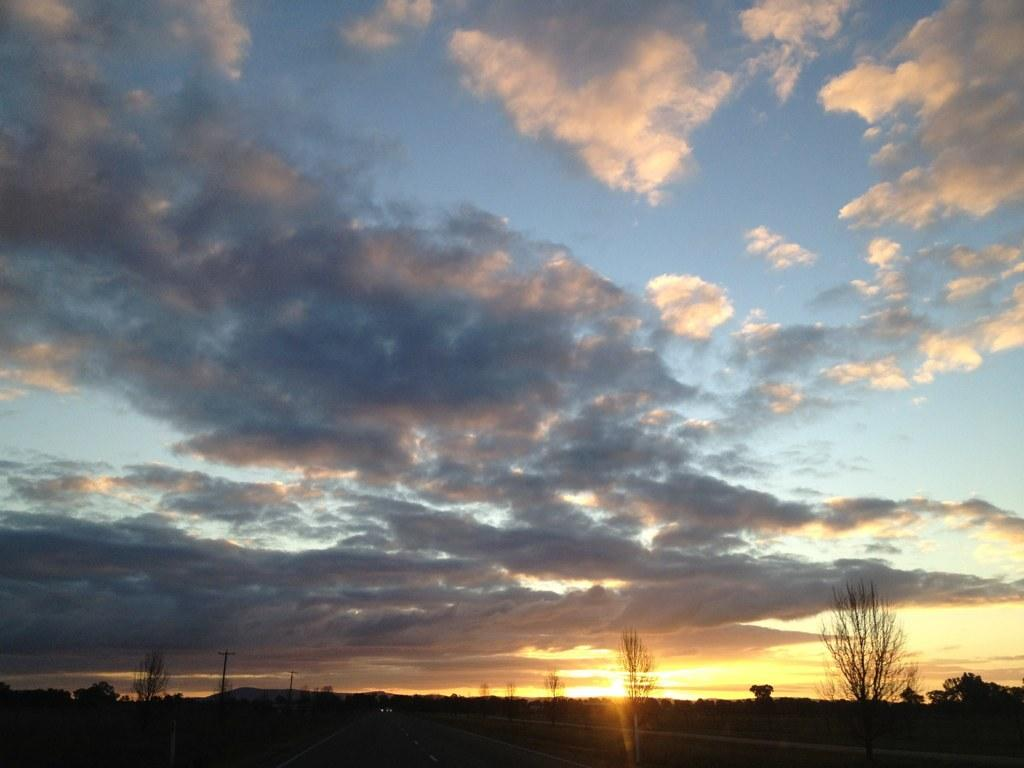What is the color and condition of the sky in the image? The sky in the image is blue and cloudy. What type of natural vegetation can be seen in the image? There are trees visible in the image. How many legs can be seen on the giants in the image? There are no giants present in the image, so it is not possible to determine the number of legs they might have. 